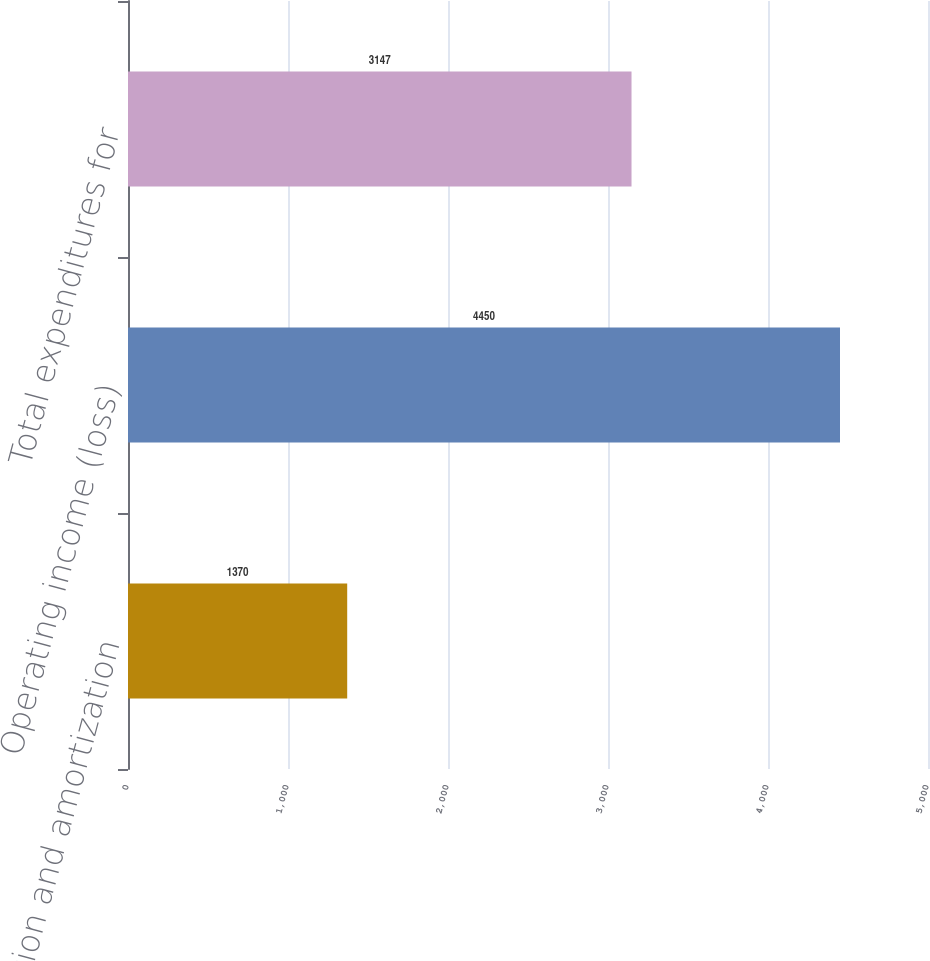Convert chart to OTSL. <chart><loc_0><loc_0><loc_500><loc_500><bar_chart><fcel>Depreciation and amortization<fcel>Operating income (loss)<fcel>Total expenditures for<nl><fcel>1370<fcel>4450<fcel>3147<nl></chart> 